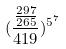Convert formula to latex. <formula><loc_0><loc_0><loc_500><loc_500>( \frac { \frac { 2 9 7 } { 2 6 5 } } { 4 1 9 } ) ^ { 5 ^ { 7 } }</formula> 